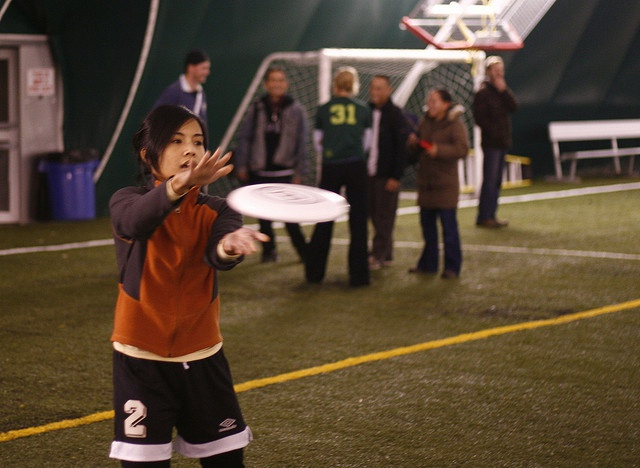Describe the objects in this image and their specific colors. I can see people in black, maroon, and brown tones, people in black, olive, gray, and maroon tones, people in black, maroon, and gray tones, people in black, maroon, and brown tones, and people in black, maroon, and brown tones in this image. 